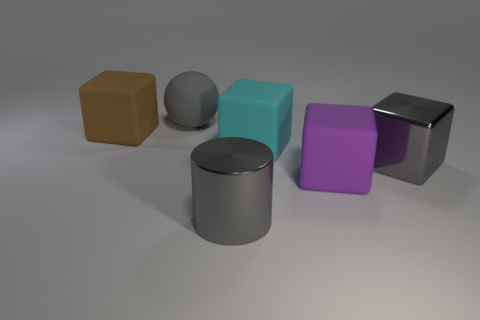Are there fewer metal cylinders that are on the left side of the metal cylinder than cylinders that are in front of the cyan block?
Give a very brief answer. Yes. What size is the sphere that is on the left side of the large purple block?
Provide a succinct answer. Large. Is there a brown block made of the same material as the large gray sphere?
Your response must be concise. Yes. Is the big cyan cube made of the same material as the large gray block?
Give a very brief answer. No. There is a shiny cube that is the same size as the purple thing; what is its color?
Offer a very short reply. Gray. What number of other objects are there of the same shape as the brown rubber thing?
Your answer should be very brief. 3. Does the rubber ball have the same size as the block that is to the left of the big ball?
Provide a succinct answer. Yes. What number of things are cylinders or tiny brown objects?
Your answer should be very brief. 1. How many other objects are there of the same size as the brown matte block?
Your answer should be very brief. 5. Does the big metallic cylinder have the same color as the object that is to the right of the big purple cube?
Give a very brief answer. Yes. 